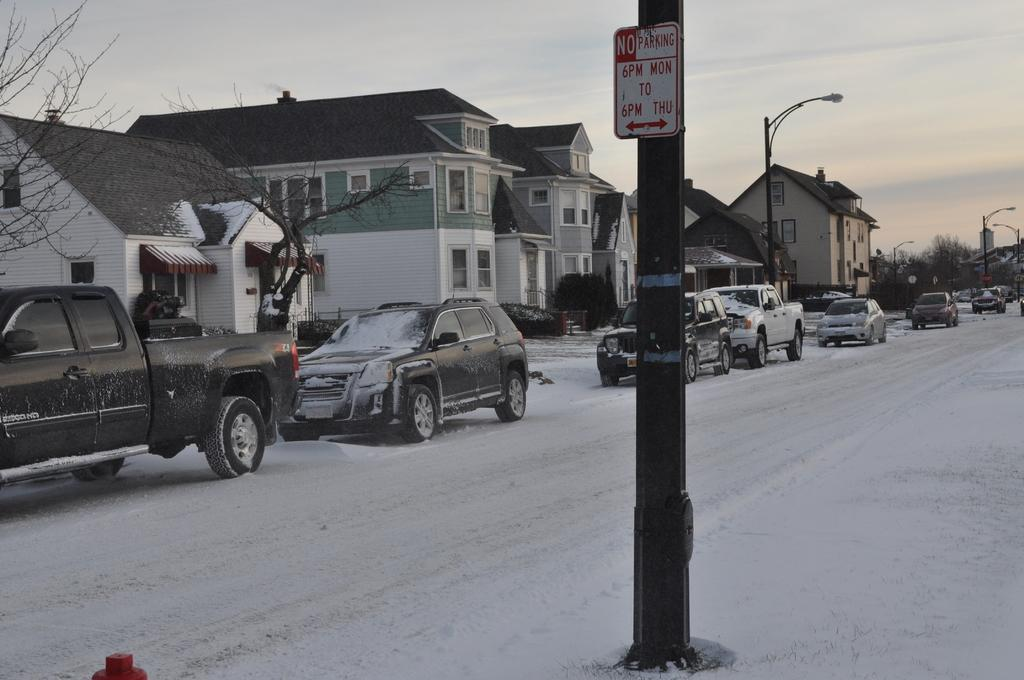What structures can be seen in the image? There are poles, boards, and light poles in the image. What is happening on the road in the image? There are fleets of vehicles on the road in the image. What type of weather is depicted in the image? There is snow visible in the image. What type of buildings can be seen in the image? There are buildings in the image. What type of vegetation is present in the image? There are trees in the image. What type of openings can be seen in the buildings? There are windows in the image. What part of the environment is visible in the image? The sky is visible in the image. What time of day is the image likely taken? The image is likely taken during the day. How many legs can be seen on the key in the image? There is no key present in the image, so it is not possible to determine the number of legs on a key. 